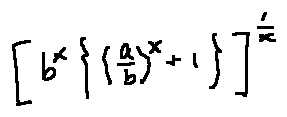Convert formula to latex. <formula><loc_0><loc_0><loc_500><loc_500>[ b ^ { x } \{ ( \frac { a } { b } ) ^ { x } + 1 \} ] ^ { \frac { 1 } { x } }</formula> 